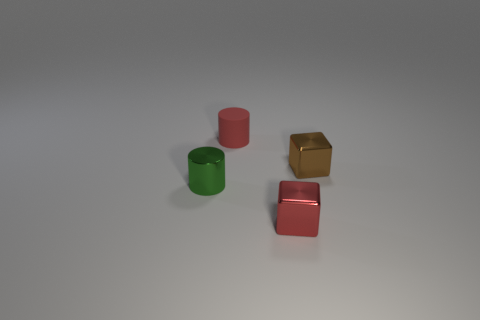How many other things are the same color as the small rubber thing? The small green rubber cylinder shares its color with no other items in this image, so there are 0 objects of the same color. 